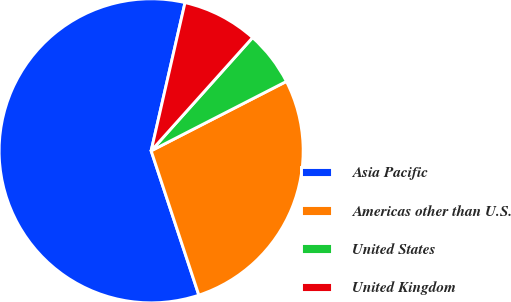<chart> <loc_0><loc_0><loc_500><loc_500><pie_chart><fcel>Asia Pacific<fcel>Americas other than U.S.<fcel>United States<fcel>United Kingdom<nl><fcel>58.65%<fcel>27.46%<fcel>5.83%<fcel>8.05%<nl></chart> 